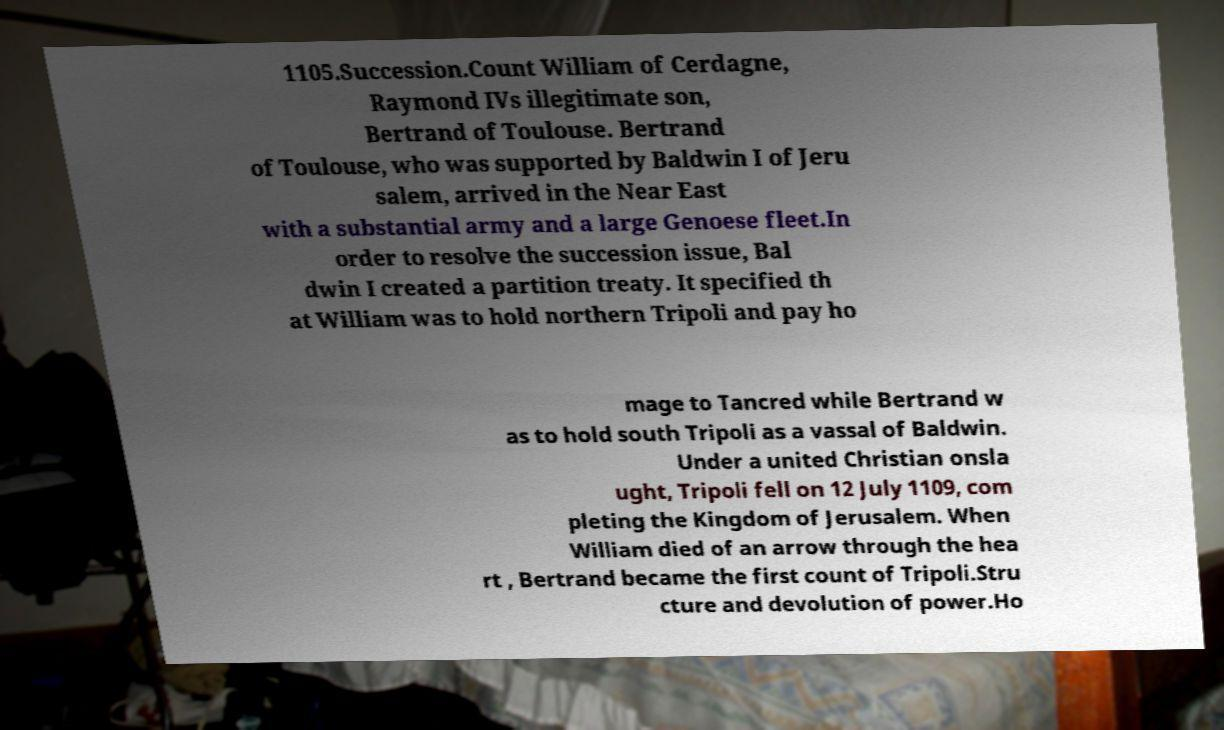For documentation purposes, I need the text within this image transcribed. Could you provide that? 1105.Succession.Count William of Cerdagne, Raymond IVs illegitimate son, Bertrand of Toulouse. Bertrand of Toulouse, who was supported by Baldwin I of Jeru salem, arrived in the Near East with a substantial army and a large Genoese fleet.In order to resolve the succession issue, Bal dwin I created a partition treaty. It specified th at William was to hold northern Tripoli and pay ho mage to Tancred while Bertrand w as to hold south Tripoli as a vassal of Baldwin. Under a united Christian onsla ught, Tripoli fell on 12 July 1109, com pleting the Kingdom of Jerusalem. When William died of an arrow through the hea rt , Bertrand became the first count of Tripoli.Stru cture and devolution of power.Ho 